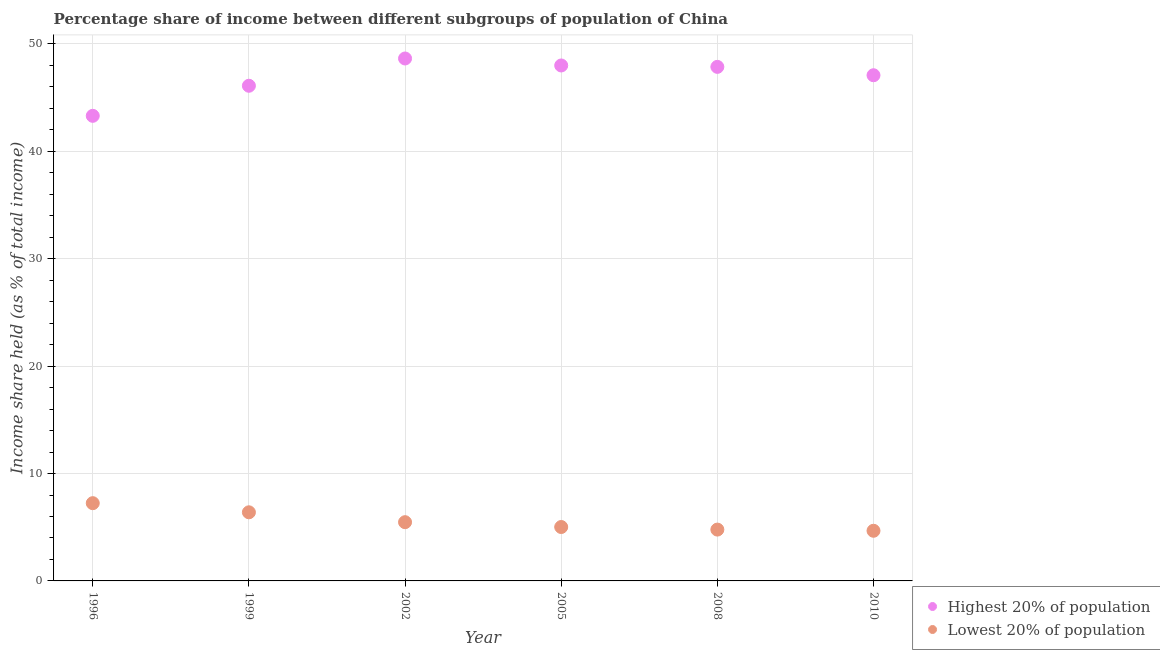How many different coloured dotlines are there?
Provide a succinct answer. 2. What is the income share held by lowest 20% of the population in 2008?
Ensure brevity in your answer.  4.78. Across all years, what is the maximum income share held by lowest 20% of the population?
Your answer should be very brief. 7.24. Across all years, what is the minimum income share held by lowest 20% of the population?
Offer a terse response. 4.67. In which year was the income share held by highest 20% of the population maximum?
Offer a terse response. 2002. In which year was the income share held by lowest 20% of the population minimum?
Make the answer very short. 2010. What is the total income share held by highest 20% of the population in the graph?
Your answer should be very brief. 281.03. What is the difference between the income share held by highest 20% of the population in 1996 and that in 1999?
Provide a succinct answer. -2.8. What is the difference between the income share held by lowest 20% of the population in 2002 and the income share held by highest 20% of the population in 1996?
Offer a terse response. -37.84. What is the average income share held by highest 20% of the population per year?
Keep it short and to the point. 46.84. In the year 2005, what is the difference between the income share held by lowest 20% of the population and income share held by highest 20% of the population?
Keep it short and to the point. -42.98. In how many years, is the income share held by lowest 20% of the population greater than 24 %?
Your answer should be compact. 0. What is the ratio of the income share held by lowest 20% of the population in 1996 to that in 2010?
Offer a very short reply. 1.55. Is the difference between the income share held by highest 20% of the population in 2002 and 2010 greater than the difference between the income share held by lowest 20% of the population in 2002 and 2010?
Provide a succinct answer. Yes. What is the difference between the highest and the second highest income share held by highest 20% of the population?
Offer a very short reply. 0.65. What is the difference between the highest and the lowest income share held by highest 20% of the population?
Your response must be concise. 5.34. In how many years, is the income share held by highest 20% of the population greater than the average income share held by highest 20% of the population taken over all years?
Offer a very short reply. 4. Does the income share held by lowest 20% of the population monotonically increase over the years?
Provide a succinct answer. No. How many dotlines are there?
Your response must be concise. 2. How many years are there in the graph?
Your answer should be compact. 6. Are the values on the major ticks of Y-axis written in scientific E-notation?
Ensure brevity in your answer.  No. Does the graph contain any zero values?
Offer a terse response. No. How many legend labels are there?
Make the answer very short. 2. What is the title of the graph?
Make the answer very short. Percentage share of income between different subgroups of population of China. What is the label or title of the Y-axis?
Keep it short and to the point. Income share held (as % of total income). What is the Income share held (as % of total income) of Highest 20% of population in 1996?
Your response must be concise. 43.31. What is the Income share held (as % of total income) of Lowest 20% of population in 1996?
Offer a very short reply. 7.24. What is the Income share held (as % of total income) in Highest 20% of population in 1999?
Provide a succinct answer. 46.11. What is the Income share held (as % of total income) in Lowest 20% of population in 1999?
Provide a succinct answer. 6.39. What is the Income share held (as % of total income) of Highest 20% of population in 2002?
Ensure brevity in your answer.  48.65. What is the Income share held (as % of total income) of Lowest 20% of population in 2002?
Keep it short and to the point. 5.47. What is the Income share held (as % of total income) of Lowest 20% of population in 2005?
Your answer should be compact. 5.02. What is the Income share held (as % of total income) of Highest 20% of population in 2008?
Ensure brevity in your answer.  47.87. What is the Income share held (as % of total income) in Lowest 20% of population in 2008?
Your response must be concise. 4.78. What is the Income share held (as % of total income) of Highest 20% of population in 2010?
Offer a terse response. 47.09. What is the Income share held (as % of total income) of Lowest 20% of population in 2010?
Keep it short and to the point. 4.67. Across all years, what is the maximum Income share held (as % of total income) in Highest 20% of population?
Provide a short and direct response. 48.65. Across all years, what is the maximum Income share held (as % of total income) in Lowest 20% of population?
Give a very brief answer. 7.24. Across all years, what is the minimum Income share held (as % of total income) in Highest 20% of population?
Offer a very short reply. 43.31. Across all years, what is the minimum Income share held (as % of total income) of Lowest 20% of population?
Keep it short and to the point. 4.67. What is the total Income share held (as % of total income) in Highest 20% of population in the graph?
Give a very brief answer. 281.03. What is the total Income share held (as % of total income) of Lowest 20% of population in the graph?
Your answer should be compact. 33.57. What is the difference between the Income share held (as % of total income) in Highest 20% of population in 1996 and that in 2002?
Your answer should be compact. -5.34. What is the difference between the Income share held (as % of total income) in Lowest 20% of population in 1996 and that in 2002?
Your answer should be compact. 1.77. What is the difference between the Income share held (as % of total income) of Highest 20% of population in 1996 and that in 2005?
Give a very brief answer. -4.69. What is the difference between the Income share held (as % of total income) in Lowest 20% of population in 1996 and that in 2005?
Ensure brevity in your answer.  2.22. What is the difference between the Income share held (as % of total income) of Highest 20% of population in 1996 and that in 2008?
Your answer should be compact. -4.56. What is the difference between the Income share held (as % of total income) of Lowest 20% of population in 1996 and that in 2008?
Ensure brevity in your answer.  2.46. What is the difference between the Income share held (as % of total income) of Highest 20% of population in 1996 and that in 2010?
Your answer should be very brief. -3.78. What is the difference between the Income share held (as % of total income) in Lowest 20% of population in 1996 and that in 2010?
Provide a short and direct response. 2.57. What is the difference between the Income share held (as % of total income) of Highest 20% of population in 1999 and that in 2002?
Keep it short and to the point. -2.54. What is the difference between the Income share held (as % of total income) of Lowest 20% of population in 1999 and that in 2002?
Offer a terse response. 0.92. What is the difference between the Income share held (as % of total income) of Highest 20% of population in 1999 and that in 2005?
Ensure brevity in your answer.  -1.89. What is the difference between the Income share held (as % of total income) in Lowest 20% of population in 1999 and that in 2005?
Keep it short and to the point. 1.37. What is the difference between the Income share held (as % of total income) of Highest 20% of population in 1999 and that in 2008?
Your answer should be compact. -1.76. What is the difference between the Income share held (as % of total income) in Lowest 20% of population in 1999 and that in 2008?
Your answer should be very brief. 1.61. What is the difference between the Income share held (as % of total income) of Highest 20% of population in 1999 and that in 2010?
Your answer should be very brief. -0.98. What is the difference between the Income share held (as % of total income) of Lowest 20% of population in 1999 and that in 2010?
Ensure brevity in your answer.  1.72. What is the difference between the Income share held (as % of total income) of Highest 20% of population in 2002 and that in 2005?
Ensure brevity in your answer.  0.65. What is the difference between the Income share held (as % of total income) in Lowest 20% of population in 2002 and that in 2005?
Your answer should be very brief. 0.45. What is the difference between the Income share held (as % of total income) of Highest 20% of population in 2002 and that in 2008?
Your answer should be compact. 0.78. What is the difference between the Income share held (as % of total income) in Lowest 20% of population in 2002 and that in 2008?
Offer a very short reply. 0.69. What is the difference between the Income share held (as % of total income) in Highest 20% of population in 2002 and that in 2010?
Make the answer very short. 1.56. What is the difference between the Income share held (as % of total income) of Highest 20% of population in 2005 and that in 2008?
Provide a succinct answer. 0.13. What is the difference between the Income share held (as % of total income) in Lowest 20% of population in 2005 and that in 2008?
Give a very brief answer. 0.24. What is the difference between the Income share held (as % of total income) in Highest 20% of population in 2005 and that in 2010?
Offer a very short reply. 0.91. What is the difference between the Income share held (as % of total income) of Lowest 20% of population in 2005 and that in 2010?
Offer a very short reply. 0.35. What is the difference between the Income share held (as % of total income) in Highest 20% of population in 2008 and that in 2010?
Provide a short and direct response. 0.78. What is the difference between the Income share held (as % of total income) of Lowest 20% of population in 2008 and that in 2010?
Your response must be concise. 0.11. What is the difference between the Income share held (as % of total income) of Highest 20% of population in 1996 and the Income share held (as % of total income) of Lowest 20% of population in 1999?
Offer a terse response. 36.92. What is the difference between the Income share held (as % of total income) of Highest 20% of population in 1996 and the Income share held (as % of total income) of Lowest 20% of population in 2002?
Keep it short and to the point. 37.84. What is the difference between the Income share held (as % of total income) of Highest 20% of population in 1996 and the Income share held (as % of total income) of Lowest 20% of population in 2005?
Your answer should be very brief. 38.29. What is the difference between the Income share held (as % of total income) of Highest 20% of population in 1996 and the Income share held (as % of total income) of Lowest 20% of population in 2008?
Your answer should be very brief. 38.53. What is the difference between the Income share held (as % of total income) of Highest 20% of population in 1996 and the Income share held (as % of total income) of Lowest 20% of population in 2010?
Provide a short and direct response. 38.64. What is the difference between the Income share held (as % of total income) in Highest 20% of population in 1999 and the Income share held (as % of total income) in Lowest 20% of population in 2002?
Make the answer very short. 40.64. What is the difference between the Income share held (as % of total income) of Highest 20% of population in 1999 and the Income share held (as % of total income) of Lowest 20% of population in 2005?
Offer a terse response. 41.09. What is the difference between the Income share held (as % of total income) of Highest 20% of population in 1999 and the Income share held (as % of total income) of Lowest 20% of population in 2008?
Give a very brief answer. 41.33. What is the difference between the Income share held (as % of total income) of Highest 20% of population in 1999 and the Income share held (as % of total income) of Lowest 20% of population in 2010?
Ensure brevity in your answer.  41.44. What is the difference between the Income share held (as % of total income) of Highest 20% of population in 2002 and the Income share held (as % of total income) of Lowest 20% of population in 2005?
Your response must be concise. 43.63. What is the difference between the Income share held (as % of total income) of Highest 20% of population in 2002 and the Income share held (as % of total income) of Lowest 20% of population in 2008?
Ensure brevity in your answer.  43.87. What is the difference between the Income share held (as % of total income) in Highest 20% of population in 2002 and the Income share held (as % of total income) in Lowest 20% of population in 2010?
Make the answer very short. 43.98. What is the difference between the Income share held (as % of total income) of Highest 20% of population in 2005 and the Income share held (as % of total income) of Lowest 20% of population in 2008?
Your response must be concise. 43.22. What is the difference between the Income share held (as % of total income) of Highest 20% of population in 2005 and the Income share held (as % of total income) of Lowest 20% of population in 2010?
Ensure brevity in your answer.  43.33. What is the difference between the Income share held (as % of total income) of Highest 20% of population in 2008 and the Income share held (as % of total income) of Lowest 20% of population in 2010?
Your answer should be compact. 43.2. What is the average Income share held (as % of total income) in Highest 20% of population per year?
Offer a terse response. 46.84. What is the average Income share held (as % of total income) of Lowest 20% of population per year?
Offer a terse response. 5.59. In the year 1996, what is the difference between the Income share held (as % of total income) in Highest 20% of population and Income share held (as % of total income) in Lowest 20% of population?
Your answer should be very brief. 36.07. In the year 1999, what is the difference between the Income share held (as % of total income) in Highest 20% of population and Income share held (as % of total income) in Lowest 20% of population?
Provide a short and direct response. 39.72. In the year 2002, what is the difference between the Income share held (as % of total income) of Highest 20% of population and Income share held (as % of total income) of Lowest 20% of population?
Keep it short and to the point. 43.18. In the year 2005, what is the difference between the Income share held (as % of total income) of Highest 20% of population and Income share held (as % of total income) of Lowest 20% of population?
Give a very brief answer. 42.98. In the year 2008, what is the difference between the Income share held (as % of total income) of Highest 20% of population and Income share held (as % of total income) of Lowest 20% of population?
Ensure brevity in your answer.  43.09. In the year 2010, what is the difference between the Income share held (as % of total income) in Highest 20% of population and Income share held (as % of total income) in Lowest 20% of population?
Your response must be concise. 42.42. What is the ratio of the Income share held (as % of total income) in Highest 20% of population in 1996 to that in 1999?
Keep it short and to the point. 0.94. What is the ratio of the Income share held (as % of total income) of Lowest 20% of population in 1996 to that in 1999?
Keep it short and to the point. 1.13. What is the ratio of the Income share held (as % of total income) in Highest 20% of population in 1996 to that in 2002?
Ensure brevity in your answer.  0.89. What is the ratio of the Income share held (as % of total income) in Lowest 20% of population in 1996 to that in 2002?
Offer a very short reply. 1.32. What is the ratio of the Income share held (as % of total income) of Highest 20% of population in 1996 to that in 2005?
Keep it short and to the point. 0.9. What is the ratio of the Income share held (as % of total income) in Lowest 20% of population in 1996 to that in 2005?
Ensure brevity in your answer.  1.44. What is the ratio of the Income share held (as % of total income) in Highest 20% of population in 1996 to that in 2008?
Offer a very short reply. 0.9. What is the ratio of the Income share held (as % of total income) of Lowest 20% of population in 1996 to that in 2008?
Offer a terse response. 1.51. What is the ratio of the Income share held (as % of total income) in Highest 20% of population in 1996 to that in 2010?
Make the answer very short. 0.92. What is the ratio of the Income share held (as % of total income) in Lowest 20% of population in 1996 to that in 2010?
Your response must be concise. 1.55. What is the ratio of the Income share held (as % of total income) in Highest 20% of population in 1999 to that in 2002?
Provide a succinct answer. 0.95. What is the ratio of the Income share held (as % of total income) in Lowest 20% of population in 1999 to that in 2002?
Provide a short and direct response. 1.17. What is the ratio of the Income share held (as % of total income) of Highest 20% of population in 1999 to that in 2005?
Provide a short and direct response. 0.96. What is the ratio of the Income share held (as % of total income) in Lowest 20% of population in 1999 to that in 2005?
Your answer should be compact. 1.27. What is the ratio of the Income share held (as % of total income) of Highest 20% of population in 1999 to that in 2008?
Your response must be concise. 0.96. What is the ratio of the Income share held (as % of total income) in Lowest 20% of population in 1999 to that in 2008?
Provide a succinct answer. 1.34. What is the ratio of the Income share held (as % of total income) in Highest 20% of population in 1999 to that in 2010?
Offer a terse response. 0.98. What is the ratio of the Income share held (as % of total income) in Lowest 20% of population in 1999 to that in 2010?
Keep it short and to the point. 1.37. What is the ratio of the Income share held (as % of total income) of Highest 20% of population in 2002 to that in 2005?
Your answer should be compact. 1.01. What is the ratio of the Income share held (as % of total income) in Lowest 20% of population in 2002 to that in 2005?
Your answer should be very brief. 1.09. What is the ratio of the Income share held (as % of total income) in Highest 20% of population in 2002 to that in 2008?
Offer a terse response. 1.02. What is the ratio of the Income share held (as % of total income) of Lowest 20% of population in 2002 to that in 2008?
Offer a terse response. 1.14. What is the ratio of the Income share held (as % of total income) in Highest 20% of population in 2002 to that in 2010?
Provide a short and direct response. 1.03. What is the ratio of the Income share held (as % of total income) in Lowest 20% of population in 2002 to that in 2010?
Provide a short and direct response. 1.17. What is the ratio of the Income share held (as % of total income) of Highest 20% of population in 2005 to that in 2008?
Give a very brief answer. 1. What is the ratio of the Income share held (as % of total income) of Lowest 20% of population in 2005 to that in 2008?
Your answer should be very brief. 1.05. What is the ratio of the Income share held (as % of total income) of Highest 20% of population in 2005 to that in 2010?
Provide a short and direct response. 1.02. What is the ratio of the Income share held (as % of total income) of Lowest 20% of population in 2005 to that in 2010?
Ensure brevity in your answer.  1.07. What is the ratio of the Income share held (as % of total income) in Highest 20% of population in 2008 to that in 2010?
Keep it short and to the point. 1.02. What is the ratio of the Income share held (as % of total income) of Lowest 20% of population in 2008 to that in 2010?
Provide a short and direct response. 1.02. What is the difference between the highest and the second highest Income share held (as % of total income) in Highest 20% of population?
Provide a succinct answer. 0.65. What is the difference between the highest and the lowest Income share held (as % of total income) in Highest 20% of population?
Give a very brief answer. 5.34. What is the difference between the highest and the lowest Income share held (as % of total income) of Lowest 20% of population?
Your response must be concise. 2.57. 